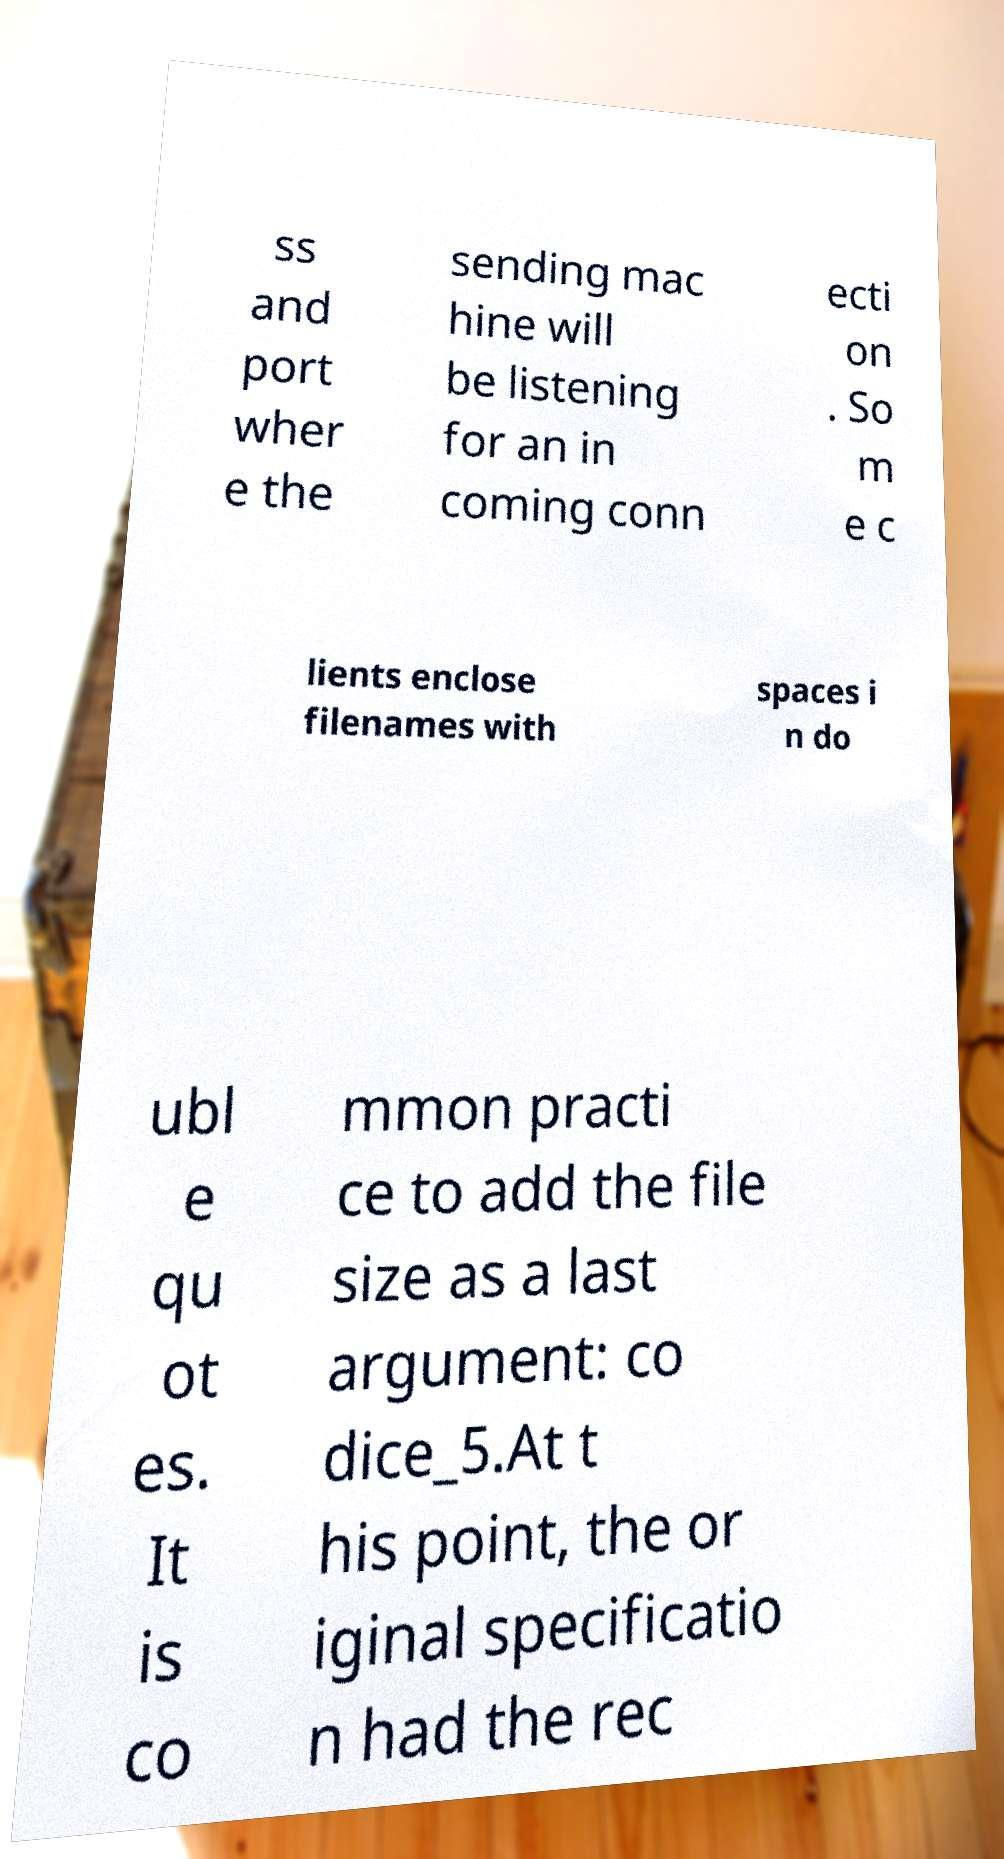Please read and relay the text visible in this image. What does it say? ss and port wher e the sending mac hine will be listening for an in coming conn ecti on . So m e c lients enclose filenames with spaces i n do ubl e qu ot es. It is co mmon practi ce to add the file size as a last argument: co dice_5.At t his point, the or iginal specificatio n had the rec 